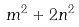Convert formula to latex. <formula><loc_0><loc_0><loc_500><loc_500>m ^ { 2 } + 2 n ^ { 2 }</formula> 